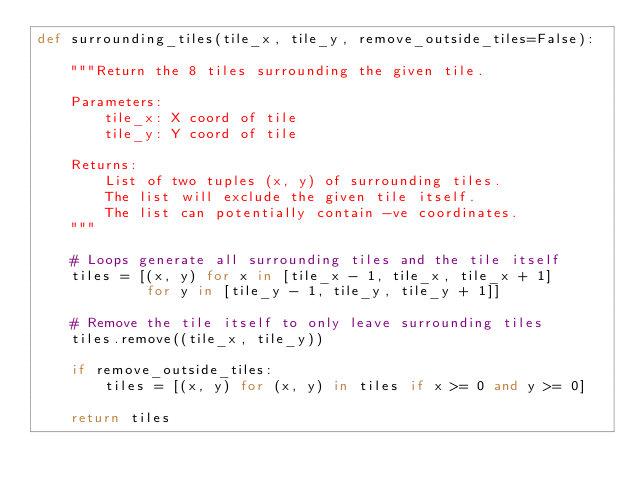<code> <loc_0><loc_0><loc_500><loc_500><_Python_>def surrounding_tiles(tile_x, tile_y, remove_outside_tiles=False):

    """Return the 8 tiles surrounding the given tile.

    Parameters:
        tile_x: X coord of tile
        tile_y: Y coord of tile

    Returns:
        List of two tuples (x, y) of surrounding tiles.
        The list will exclude the given tile itself.
        The list can potentially contain -ve coordinates.
    """

    # Loops generate all surrounding tiles and the tile itself
    tiles = [(x, y) for x in [tile_x - 1, tile_x, tile_x + 1]
             for y in [tile_y - 1, tile_y, tile_y + 1]]

    # Remove the tile itself to only leave surrounding tiles
    tiles.remove((tile_x, tile_y))

    if remove_outside_tiles:
        tiles = [(x, y) for (x, y) in tiles if x >= 0 and y >= 0]

    return tiles
</code> 